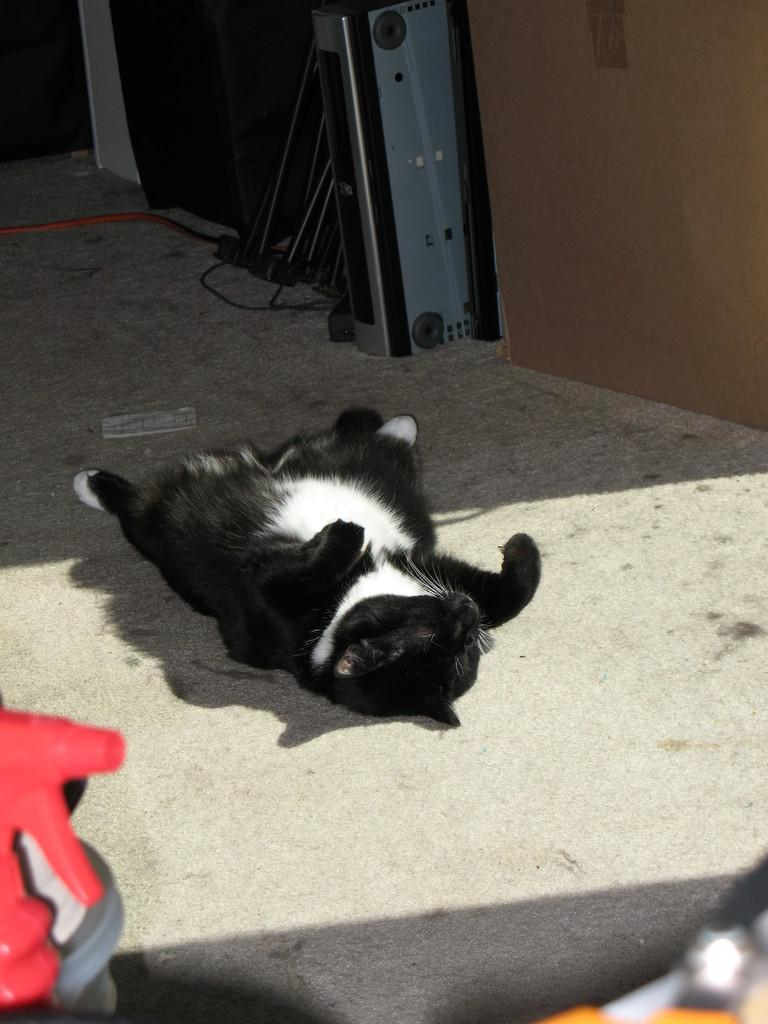What type of animal is in the image? There is a black and white colored cat in the image. Where is the cat located in the image? The cat is on the floor. What else can be seen in the image besides the cat? There is a paper and other objects in the image. Where is the playground located in the image? There is no playground present in the image. What type of locket is the cat wearing in the image? The cat is not wearing a locket in the image. 